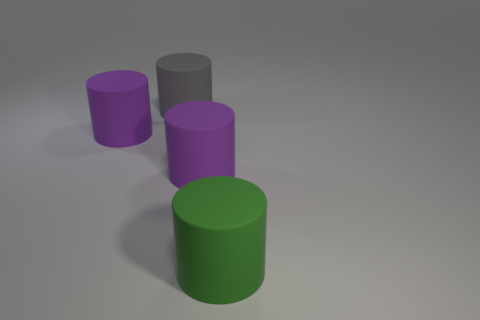What number of other objects are there of the same shape as the green object?
Your response must be concise. 3. The large matte thing behind the big purple rubber cylinder on the left side of the gray thing is what color?
Your response must be concise. Gray. What number of rubber things are blue things or big things?
Provide a short and direct response. 4. How many green cylinders are behind the thing that is to the left of the gray rubber object?
Keep it short and to the point. 0. How many objects are either large purple things or rubber cylinders that are on the left side of the green matte object?
Your answer should be compact. 3. Are there any big green cylinders made of the same material as the green object?
Keep it short and to the point. No. What number of big cylinders are in front of the large gray rubber cylinder and behind the large green cylinder?
Your response must be concise. 2. What is the size of the green cylinder that is made of the same material as the large gray cylinder?
Provide a short and direct response. Large. There is a big gray cylinder; are there any matte cylinders in front of it?
Offer a terse response. Yes. There is a green rubber thing that is the same shape as the big gray thing; what is its size?
Keep it short and to the point. Large. 